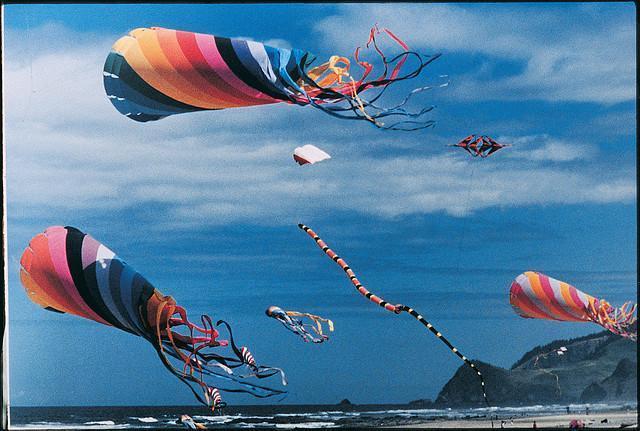How many kites are flying?
Give a very brief answer. 6. How many kites are there?
Give a very brief answer. 4. 